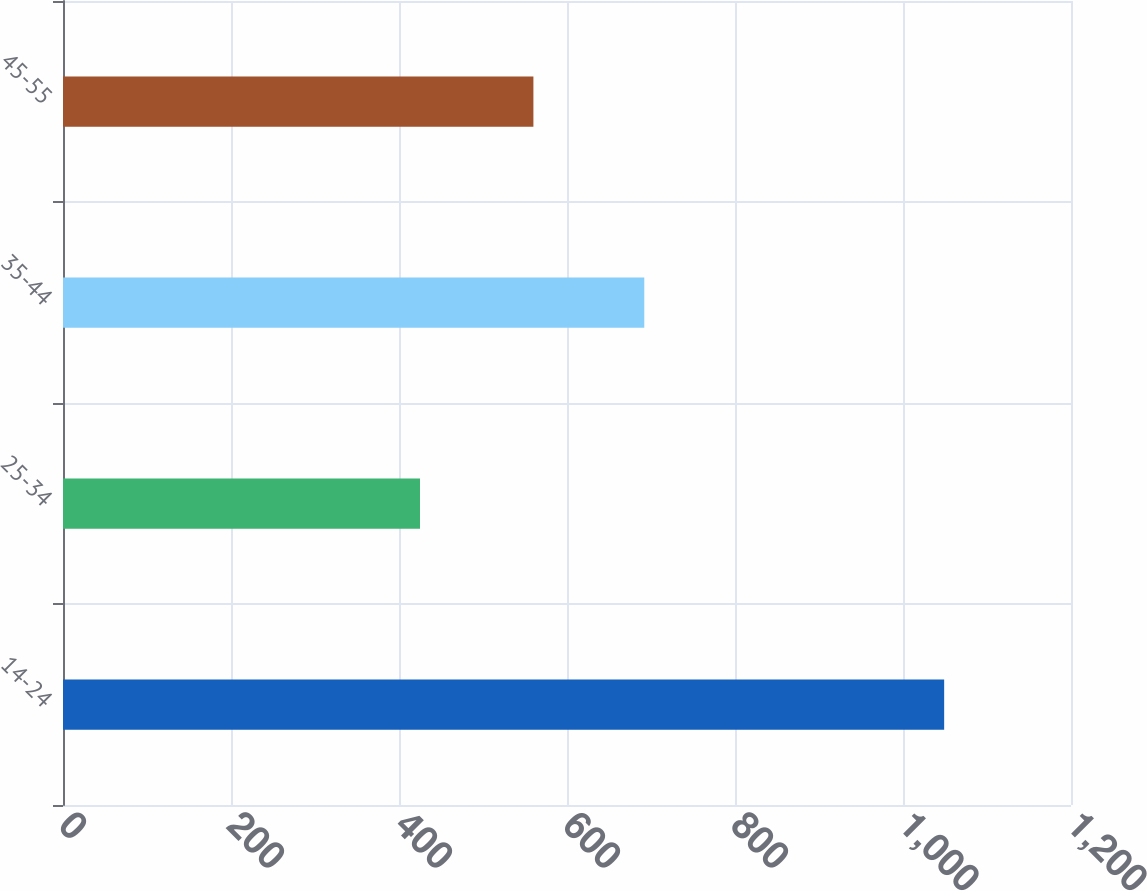Convert chart to OTSL. <chart><loc_0><loc_0><loc_500><loc_500><bar_chart><fcel>14-24<fcel>25-34<fcel>35-44<fcel>45-55<nl><fcel>1049<fcel>425<fcel>692<fcel>560<nl></chart> 